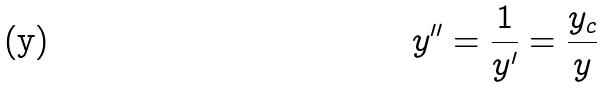<formula> <loc_0><loc_0><loc_500><loc_500>y ^ { \prime \prime } = \frac { 1 } { y ^ { \prime } } = \frac { y _ { c } } { y }</formula> 